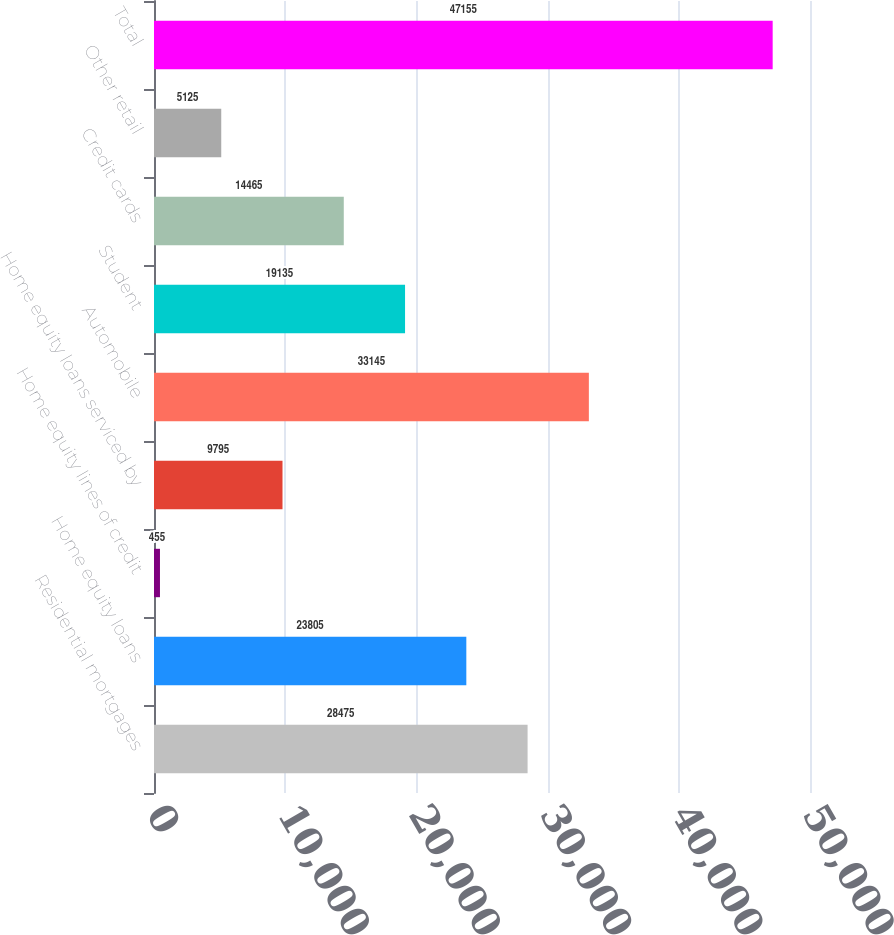<chart> <loc_0><loc_0><loc_500><loc_500><bar_chart><fcel>Residential mortgages<fcel>Home equity loans<fcel>Home equity lines of credit<fcel>Home equity loans serviced by<fcel>Automobile<fcel>Student<fcel>Credit cards<fcel>Other retail<fcel>Total<nl><fcel>28475<fcel>23805<fcel>455<fcel>9795<fcel>33145<fcel>19135<fcel>14465<fcel>5125<fcel>47155<nl></chart> 